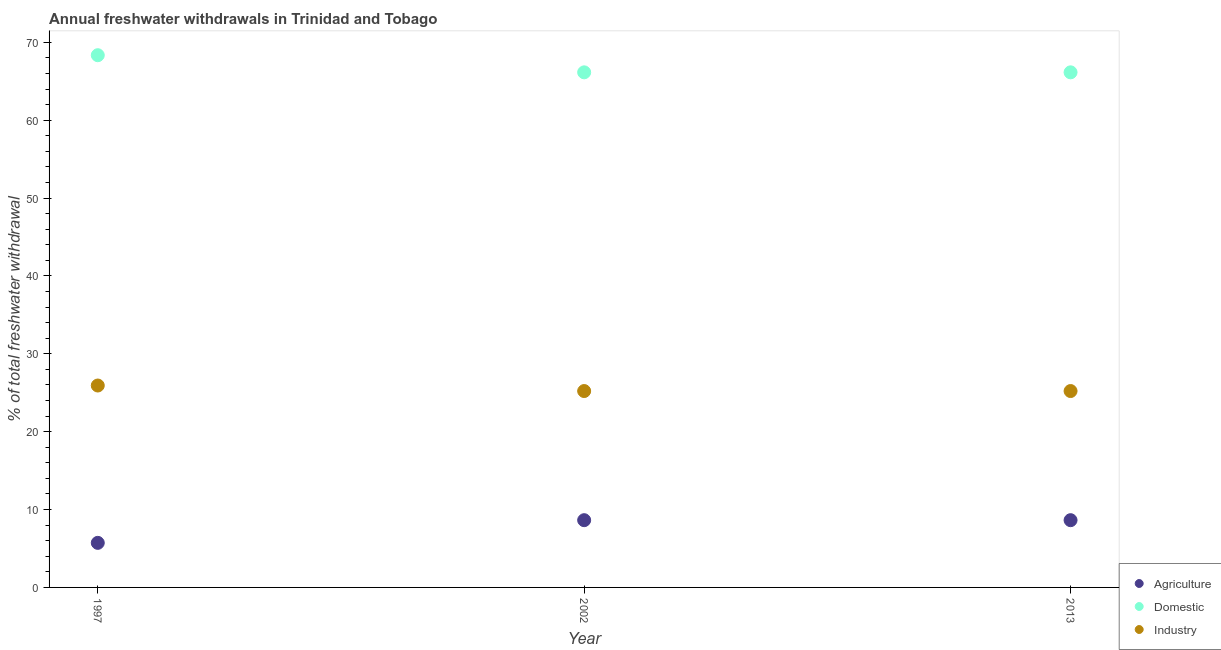How many different coloured dotlines are there?
Provide a short and direct response. 3. Is the number of dotlines equal to the number of legend labels?
Ensure brevity in your answer.  Yes. What is the percentage of freshwater withdrawal for domestic purposes in 2013?
Your answer should be compact. 66.15. Across all years, what is the maximum percentage of freshwater withdrawal for agriculture?
Provide a short and direct response. 8.64. Across all years, what is the minimum percentage of freshwater withdrawal for agriculture?
Give a very brief answer. 5.72. In which year was the percentage of freshwater withdrawal for agriculture maximum?
Provide a short and direct response. 2002. In which year was the percentage of freshwater withdrawal for domestic purposes minimum?
Offer a very short reply. 2002. What is the total percentage of freshwater withdrawal for agriculture in the graph?
Offer a very short reply. 23. What is the difference between the percentage of freshwater withdrawal for domestic purposes in 2002 and that in 2013?
Offer a terse response. 0. What is the difference between the percentage of freshwater withdrawal for domestic purposes in 1997 and the percentage of freshwater withdrawal for agriculture in 2013?
Ensure brevity in your answer.  59.71. What is the average percentage of freshwater withdrawal for agriculture per year?
Your response must be concise. 7.67. In the year 2002, what is the difference between the percentage of freshwater withdrawal for domestic purposes and percentage of freshwater withdrawal for agriculture?
Provide a short and direct response. 57.51. What is the ratio of the percentage of freshwater withdrawal for agriculture in 2002 to that in 2013?
Your answer should be very brief. 1. Is the percentage of freshwater withdrawal for agriculture in 2002 less than that in 2013?
Provide a succinct answer. No. What is the difference between the highest and the second highest percentage of freshwater withdrawal for industry?
Offer a terse response. 0.71. What is the difference between the highest and the lowest percentage of freshwater withdrawal for domestic purposes?
Your answer should be compact. 2.2. In how many years, is the percentage of freshwater withdrawal for industry greater than the average percentage of freshwater withdrawal for industry taken over all years?
Offer a terse response. 1. Is it the case that in every year, the sum of the percentage of freshwater withdrawal for agriculture and percentage of freshwater withdrawal for domestic purposes is greater than the percentage of freshwater withdrawal for industry?
Provide a succinct answer. Yes. Is the percentage of freshwater withdrawal for domestic purposes strictly greater than the percentage of freshwater withdrawal for industry over the years?
Provide a succinct answer. Yes. Are the values on the major ticks of Y-axis written in scientific E-notation?
Provide a short and direct response. No. Where does the legend appear in the graph?
Provide a succinct answer. Bottom right. How are the legend labels stacked?
Your answer should be very brief. Vertical. What is the title of the graph?
Keep it short and to the point. Annual freshwater withdrawals in Trinidad and Tobago. What is the label or title of the Y-axis?
Make the answer very short. % of total freshwater withdrawal. What is the % of total freshwater withdrawal in Agriculture in 1997?
Offer a very short reply. 5.72. What is the % of total freshwater withdrawal of Domestic in 1997?
Provide a short and direct response. 68.35. What is the % of total freshwater withdrawal of Industry in 1997?
Ensure brevity in your answer.  25.93. What is the % of total freshwater withdrawal of Agriculture in 2002?
Your response must be concise. 8.64. What is the % of total freshwater withdrawal in Domestic in 2002?
Your answer should be very brief. 66.15. What is the % of total freshwater withdrawal of Industry in 2002?
Offer a very short reply. 25.22. What is the % of total freshwater withdrawal in Agriculture in 2013?
Your answer should be compact. 8.64. What is the % of total freshwater withdrawal in Domestic in 2013?
Keep it short and to the point. 66.15. What is the % of total freshwater withdrawal of Industry in 2013?
Provide a succinct answer. 25.22. Across all years, what is the maximum % of total freshwater withdrawal in Agriculture?
Make the answer very short. 8.64. Across all years, what is the maximum % of total freshwater withdrawal of Domestic?
Provide a short and direct response. 68.35. Across all years, what is the maximum % of total freshwater withdrawal in Industry?
Keep it short and to the point. 25.93. Across all years, what is the minimum % of total freshwater withdrawal in Agriculture?
Your answer should be very brief. 5.72. Across all years, what is the minimum % of total freshwater withdrawal in Domestic?
Provide a short and direct response. 66.15. Across all years, what is the minimum % of total freshwater withdrawal in Industry?
Provide a succinct answer. 25.22. What is the total % of total freshwater withdrawal of Agriculture in the graph?
Make the answer very short. 23. What is the total % of total freshwater withdrawal in Domestic in the graph?
Provide a short and direct response. 200.65. What is the total % of total freshwater withdrawal in Industry in the graph?
Keep it short and to the point. 76.37. What is the difference between the % of total freshwater withdrawal in Agriculture in 1997 and that in 2002?
Ensure brevity in your answer.  -2.91. What is the difference between the % of total freshwater withdrawal in Domestic in 1997 and that in 2002?
Provide a short and direct response. 2.2. What is the difference between the % of total freshwater withdrawal in Industry in 1997 and that in 2002?
Your answer should be very brief. 0.71. What is the difference between the % of total freshwater withdrawal in Agriculture in 1997 and that in 2013?
Give a very brief answer. -2.91. What is the difference between the % of total freshwater withdrawal in Domestic in 1997 and that in 2013?
Keep it short and to the point. 2.2. What is the difference between the % of total freshwater withdrawal in Industry in 1997 and that in 2013?
Your response must be concise. 0.71. What is the difference between the % of total freshwater withdrawal of Domestic in 2002 and that in 2013?
Offer a very short reply. 0. What is the difference between the % of total freshwater withdrawal in Industry in 2002 and that in 2013?
Your answer should be compact. 0. What is the difference between the % of total freshwater withdrawal in Agriculture in 1997 and the % of total freshwater withdrawal in Domestic in 2002?
Ensure brevity in your answer.  -60.43. What is the difference between the % of total freshwater withdrawal of Agriculture in 1997 and the % of total freshwater withdrawal of Industry in 2002?
Your answer should be very brief. -19.5. What is the difference between the % of total freshwater withdrawal in Domestic in 1997 and the % of total freshwater withdrawal in Industry in 2002?
Provide a short and direct response. 43.13. What is the difference between the % of total freshwater withdrawal of Agriculture in 1997 and the % of total freshwater withdrawal of Domestic in 2013?
Keep it short and to the point. -60.43. What is the difference between the % of total freshwater withdrawal of Agriculture in 1997 and the % of total freshwater withdrawal of Industry in 2013?
Your response must be concise. -19.5. What is the difference between the % of total freshwater withdrawal of Domestic in 1997 and the % of total freshwater withdrawal of Industry in 2013?
Offer a terse response. 43.13. What is the difference between the % of total freshwater withdrawal of Agriculture in 2002 and the % of total freshwater withdrawal of Domestic in 2013?
Your answer should be very brief. -57.51. What is the difference between the % of total freshwater withdrawal in Agriculture in 2002 and the % of total freshwater withdrawal in Industry in 2013?
Give a very brief answer. -16.58. What is the difference between the % of total freshwater withdrawal in Domestic in 2002 and the % of total freshwater withdrawal in Industry in 2013?
Your answer should be very brief. 40.93. What is the average % of total freshwater withdrawal of Agriculture per year?
Keep it short and to the point. 7.67. What is the average % of total freshwater withdrawal of Domestic per year?
Your response must be concise. 66.88. What is the average % of total freshwater withdrawal in Industry per year?
Offer a very short reply. 25.46. In the year 1997, what is the difference between the % of total freshwater withdrawal in Agriculture and % of total freshwater withdrawal in Domestic?
Your answer should be very brief. -62.63. In the year 1997, what is the difference between the % of total freshwater withdrawal in Agriculture and % of total freshwater withdrawal in Industry?
Offer a very short reply. -20.21. In the year 1997, what is the difference between the % of total freshwater withdrawal of Domestic and % of total freshwater withdrawal of Industry?
Provide a succinct answer. 42.42. In the year 2002, what is the difference between the % of total freshwater withdrawal of Agriculture and % of total freshwater withdrawal of Domestic?
Your response must be concise. -57.51. In the year 2002, what is the difference between the % of total freshwater withdrawal of Agriculture and % of total freshwater withdrawal of Industry?
Offer a very short reply. -16.58. In the year 2002, what is the difference between the % of total freshwater withdrawal of Domestic and % of total freshwater withdrawal of Industry?
Provide a succinct answer. 40.93. In the year 2013, what is the difference between the % of total freshwater withdrawal of Agriculture and % of total freshwater withdrawal of Domestic?
Your answer should be compact. -57.51. In the year 2013, what is the difference between the % of total freshwater withdrawal of Agriculture and % of total freshwater withdrawal of Industry?
Give a very brief answer. -16.58. In the year 2013, what is the difference between the % of total freshwater withdrawal in Domestic and % of total freshwater withdrawal in Industry?
Keep it short and to the point. 40.93. What is the ratio of the % of total freshwater withdrawal of Agriculture in 1997 to that in 2002?
Ensure brevity in your answer.  0.66. What is the ratio of the % of total freshwater withdrawal in Industry in 1997 to that in 2002?
Give a very brief answer. 1.03. What is the ratio of the % of total freshwater withdrawal in Agriculture in 1997 to that in 2013?
Your response must be concise. 0.66. What is the ratio of the % of total freshwater withdrawal in Industry in 1997 to that in 2013?
Give a very brief answer. 1.03. What is the ratio of the % of total freshwater withdrawal in Agriculture in 2002 to that in 2013?
Make the answer very short. 1. What is the ratio of the % of total freshwater withdrawal of Domestic in 2002 to that in 2013?
Keep it short and to the point. 1. What is the difference between the highest and the second highest % of total freshwater withdrawal in Domestic?
Make the answer very short. 2.2. What is the difference between the highest and the second highest % of total freshwater withdrawal in Industry?
Provide a succinct answer. 0.71. What is the difference between the highest and the lowest % of total freshwater withdrawal in Agriculture?
Make the answer very short. 2.91. What is the difference between the highest and the lowest % of total freshwater withdrawal in Industry?
Your answer should be very brief. 0.71. 